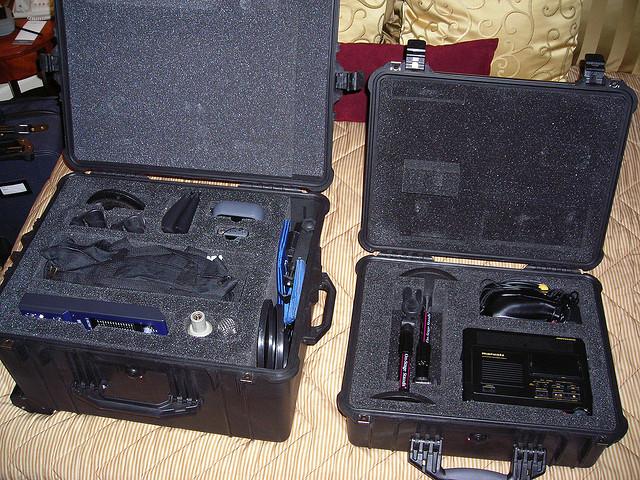Why is there so much foam in the cases?
Short answer required. Protection. What is the foam keeping in place?
Quick response, please. Tools. Is the bed made?
Be succinct. Yes. 